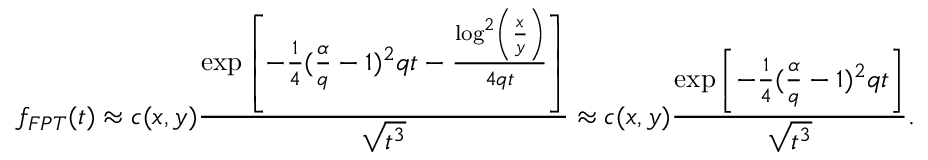<formula> <loc_0><loc_0><loc_500><loc_500>f _ { F P T } ( t ) \approx c ( x , y ) \frac { \exp \left [ - \frac { 1 } { 4 } ( \frac { \alpha } { q } - 1 ) ^ { 2 } q t - \frac { \log ^ { 2 } \left ( \frac { x } { y } \right ) } { 4 q t } \right ] } { \sqrt { t ^ { 3 } } } \approx c ( x , y ) \frac { \exp \left [ - \frac { 1 } { 4 } ( \frac { \alpha } { q } - 1 ) ^ { 2 } q t \right ] } { \sqrt { t ^ { 3 } } } .</formula> 